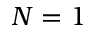Convert formula to latex. <formula><loc_0><loc_0><loc_500><loc_500>N = 1</formula> 